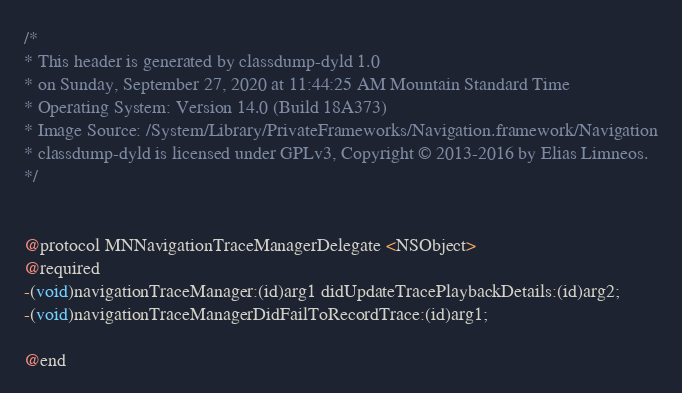Convert code to text. <code><loc_0><loc_0><loc_500><loc_500><_C_>/*
* This header is generated by classdump-dyld 1.0
* on Sunday, September 27, 2020 at 11:44:25 AM Mountain Standard Time
* Operating System: Version 14.0 (Build 18A373)
* Image Source: /System/Library/PrivateFrameworks/Navigation.framework/Navigation
* classdump-dyld is licensed under GPLv3, Copyright © 2013-2016 by Elias Limneos.
*/


@protocol MNNavigationTraceManagerDelegate <NSObject>
@required
-(void)navigationTraceManager:(id)arg1 didUpdateTracePlaybackDetails:(id)arg2;
-(void)navigationTraceManagerDidFailToRecordTrace:(id)arg1;

@end

</code> 